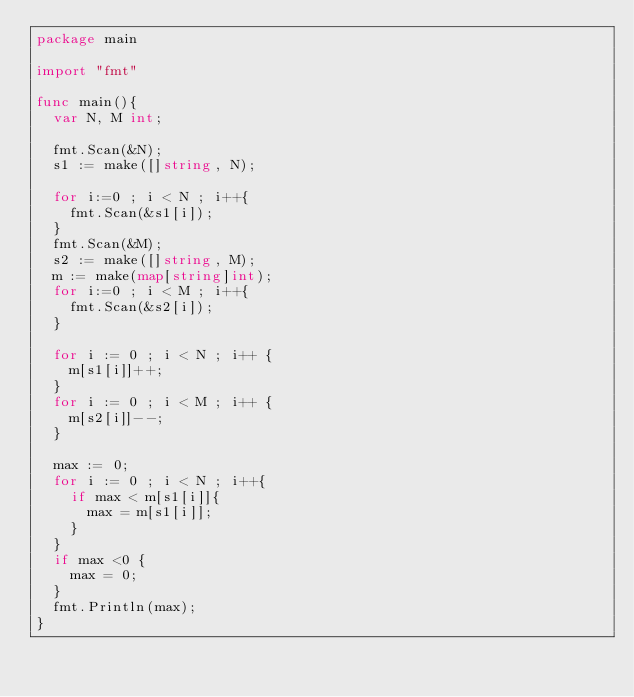<code> <loc_0><loc_0><loc_500><loc_500><_Go_>package main

import "fmt"

func main(){
	var N, M int;

	fmt.Scan(&N);
	s1 := make([]string, N);

	for i:=0 ; i < N ; i++{
		fmt.Scan(&s1[i]);
	}
	fmt.Scan(&M);
	s2 := make([]string, M);
	m := make(map[string]int);
	for i:=0 ; i < M ; i++{
		fmt.Scan(&s2[i]);
	}

	for i := 0 ; i < N ; i++ {
		m[s1[i]]++;
	}
	for i := 0 ; i < M ; i++ {
		m[s2[i]]--;
	}

	max := 0;
	for i := 0 ; i < N ; i++{
		if max < m[s1[i]]{
			max = m[s1[i]];
		}
	}
	if max <0 {
		max = 0;
	}
	fmt.Println(max);
}</code> 